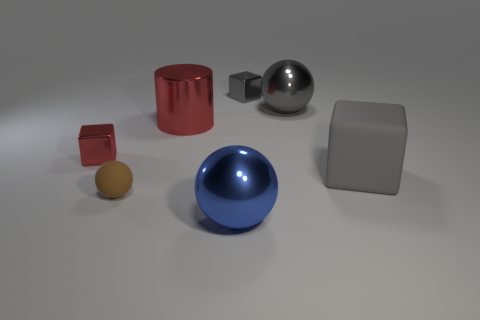There is a gray cube that is in front of the gray shiny cube; what material is it?
Provide a succinct answer. Rubber. The metal block that is the same color as the large rubber cube is what size?
Your answer should be compact. Small. How many objects are big balls behind the blue metal thing or small purple metallic objects?
Give a very brief answer. 1. Are there an equal number of big gray rubber blocks that are in front of the large gray matte thing and purple matte balls?
Offer a terse response. Yes. Does the blue shiny sphere have the same size as the brown matte thing?
Ensure brevity in your answer.  No. What color is the cylinder that is the same size as the gray metal ball?
Provide a succinct answer. Red. There is a metallic cylinder; does it have the same size as the metallic block that is in front of the tiny gray metallic thing?
Your answer should be compact. No. How many other metallic cylinders are the same color as the big metallic cylinder?
Your response must be concise. 0. What number of objects are large brown metallic objects or small shiny things that are to the left of the large metallic cylinder?
Make the answer very short. 1. There is a object in front of the tiny brown rubber sphere; is its size the same as the red thing that is to the right of the small red shiny block?
Your answer should be compact. Yes. 